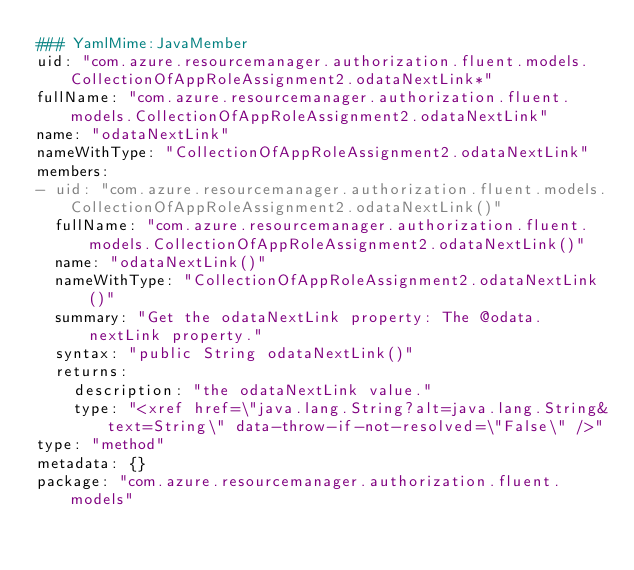Convert code to text. <code><loc_0><loc_0><loc_500><loc_500><_YAML_>### YamlMime:JavaMember
uid: "com.azure.resourcemanager.authorization.fluent.models.CollectionOfAppRoleAssignment2.odataNextLink*"
fullName: "com.azure.resourcemanager.authorization.fluent.models.CollectionOfAppRoleAssignment2.odataNextLink"
name: "odataNextLink"
nameWithType: "CollectionOfAppRoleAssignment2.odataNextLink"
members:
- uid: "com.azure.resourcemanager.authorization.fluent.models.CollectionOfAppRoleAssignment2.odataNextLink()"
  fullName: "com.azure.resourcemanager.authorization.fluent.models.CollectionOfAppRoleAssignment2.odataNextLink()"
  name: "odataNextLink()"
  nameWithType: "CollectionOfAppRoleAssignment2.odataNextLink()"
  summary: "Get the odataNextLink property: The @odata.nextLink property."
  syntax: "public String odataNextLink()"
  returns:
    description: "the odataNextLink value."
    type: "<xref href=\"java.lang.String?alt=java.lang.String&text=String\" data-throw-if-not-resolved=\"False\" />"
type: "method"
metadata: {}
package: "com.azure.resourcemanager.authorization.fluent.models"</code> 